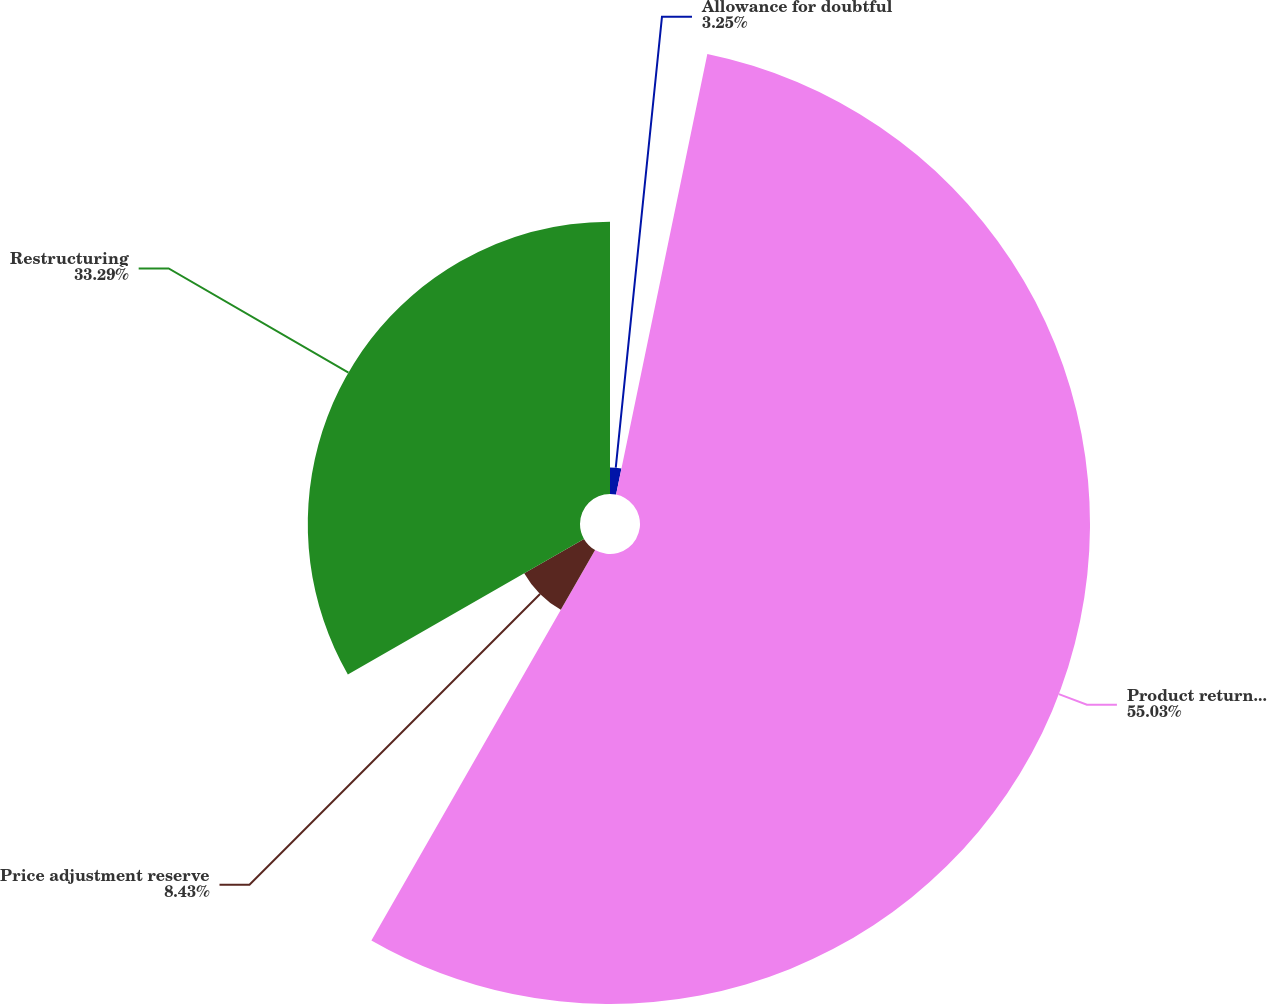<chart> <loc_0><loc_0><loc_500><loc_500><pie_chart><fcel>Allowance for doubtful<fcel>Product returns reserve<fcel>Price adjustment reserve<fcel>Restructuring<nl><fcel>3.25%<fcel>55.03%<fcel>8.43%<fcel>33.29%<nl></chart> 